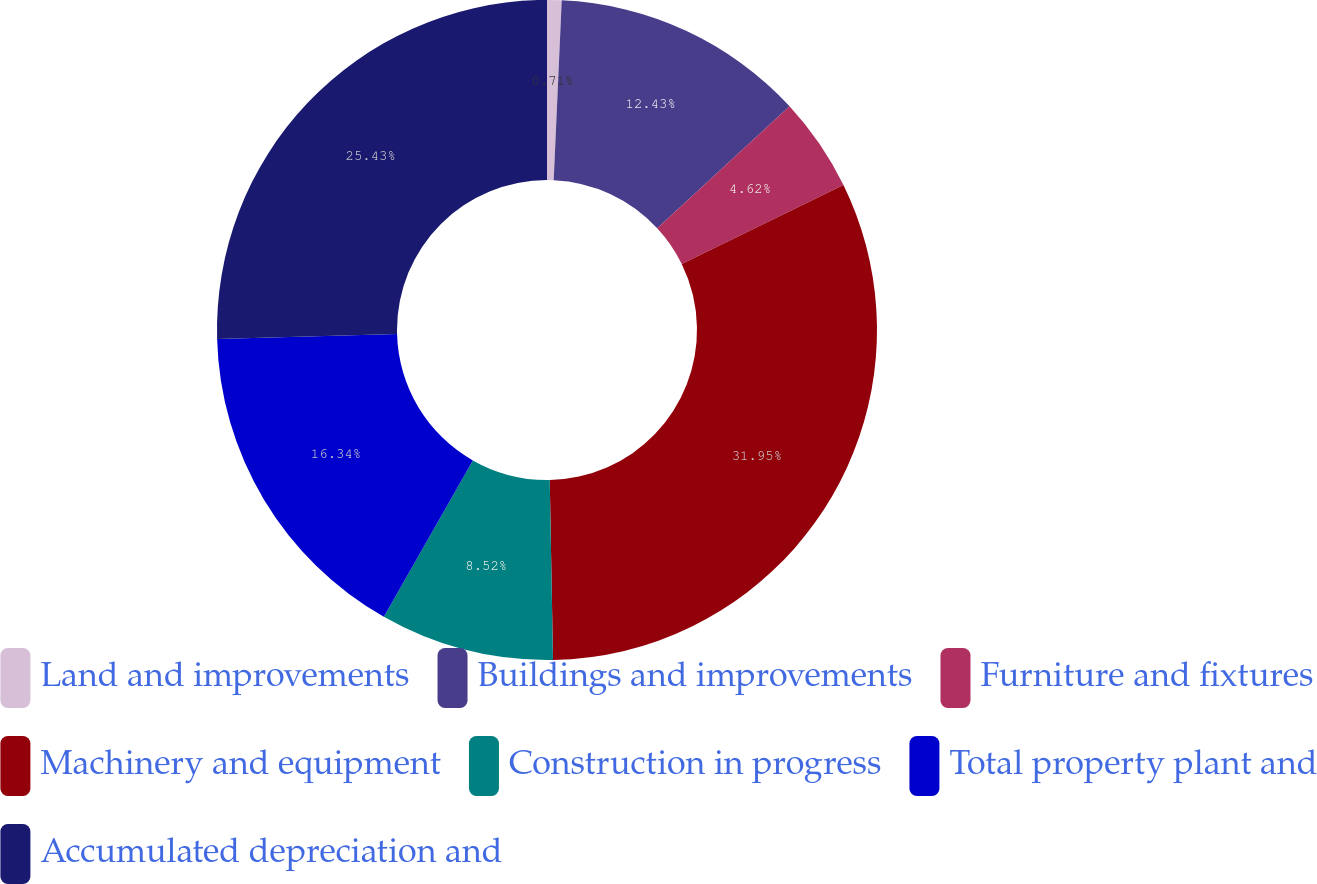Convert chart. <chart><loc_0><loc_0><loc_500><loc_500><pie_chart><fcel>Land and improvements<fcel>Buildings and improvements<fcel>Furniture and fixtures<fcel>Machinery and equipment<fcel>Construction in progress<fcel>Total property plant and<fcel>Accumulated depreciation and<nl><fcel>0.71%<fcel>12.43%<fcel>4.62%<fcel>31.95%<fcel>8.52%<fcel>16.34%<fcel>25.43%<nl></chart> 